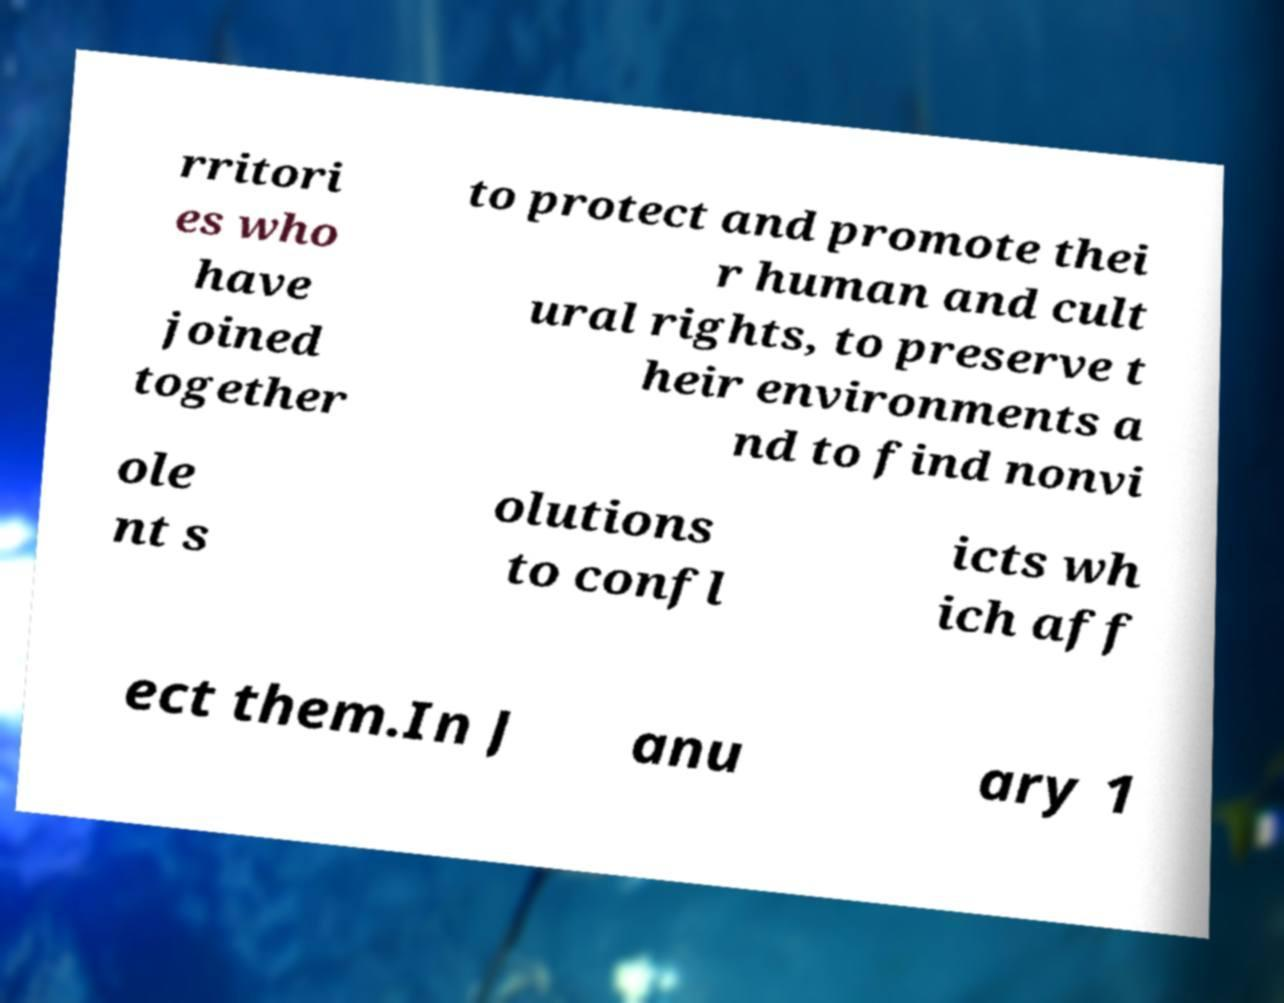Please identify and transcribe the text found in this image. rritori es who have joined together to protect and promote thei r human and cult ural rights, to preserve t heir environments a nd to find nonvi ole nt s olutions to confl icts wh ich aff ect them.In J anu ary 1 